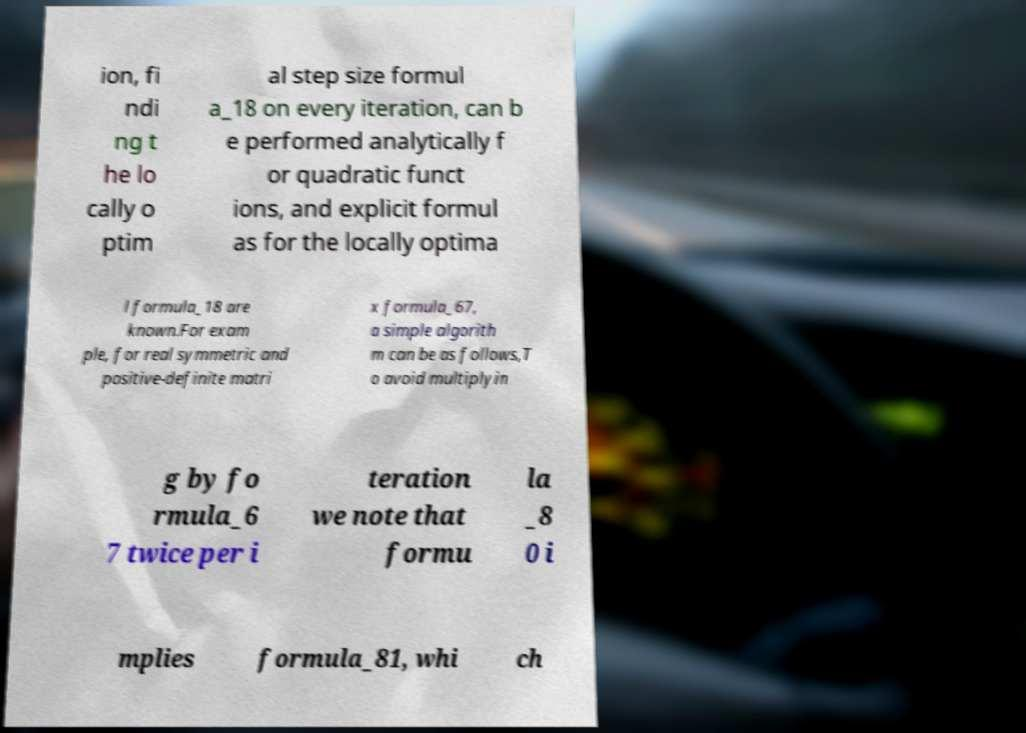Could you extract and type out the text from this image? ion, fi ndi ng t he lo cally o ptim al step size formul a_18 on every iteration, can b e performed analytically f or quadratic funct ions, and explicit formul as for the locally optima l formula_18 are known.For exam ple, for real symmetric and positive-definite matri x formula_67, a simple algorith m can be as follows,T o avoid multiplyin g by fo rmula_6 7 twice per i teration we note that formu la _8 0 i mplies formula_81, whi ch 